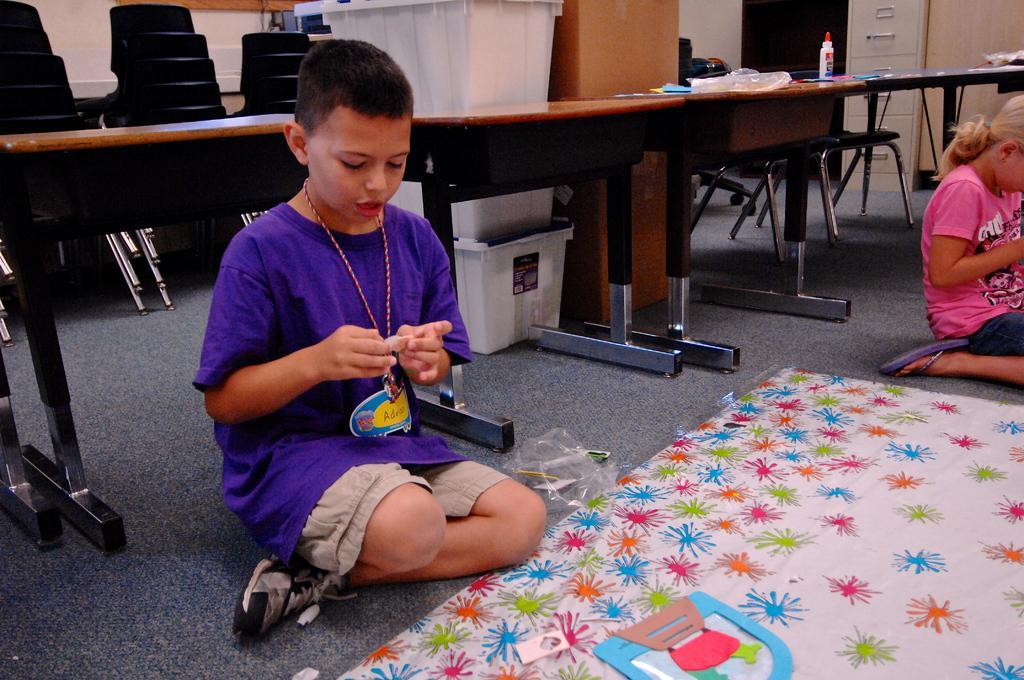Please provide a concise description of this image. In this image I can see two persons are sitting on the floor and a paper cover. In the background I can see tables, cupboards, chairs, boxes and a wall. This image is taken may be in a hall. 